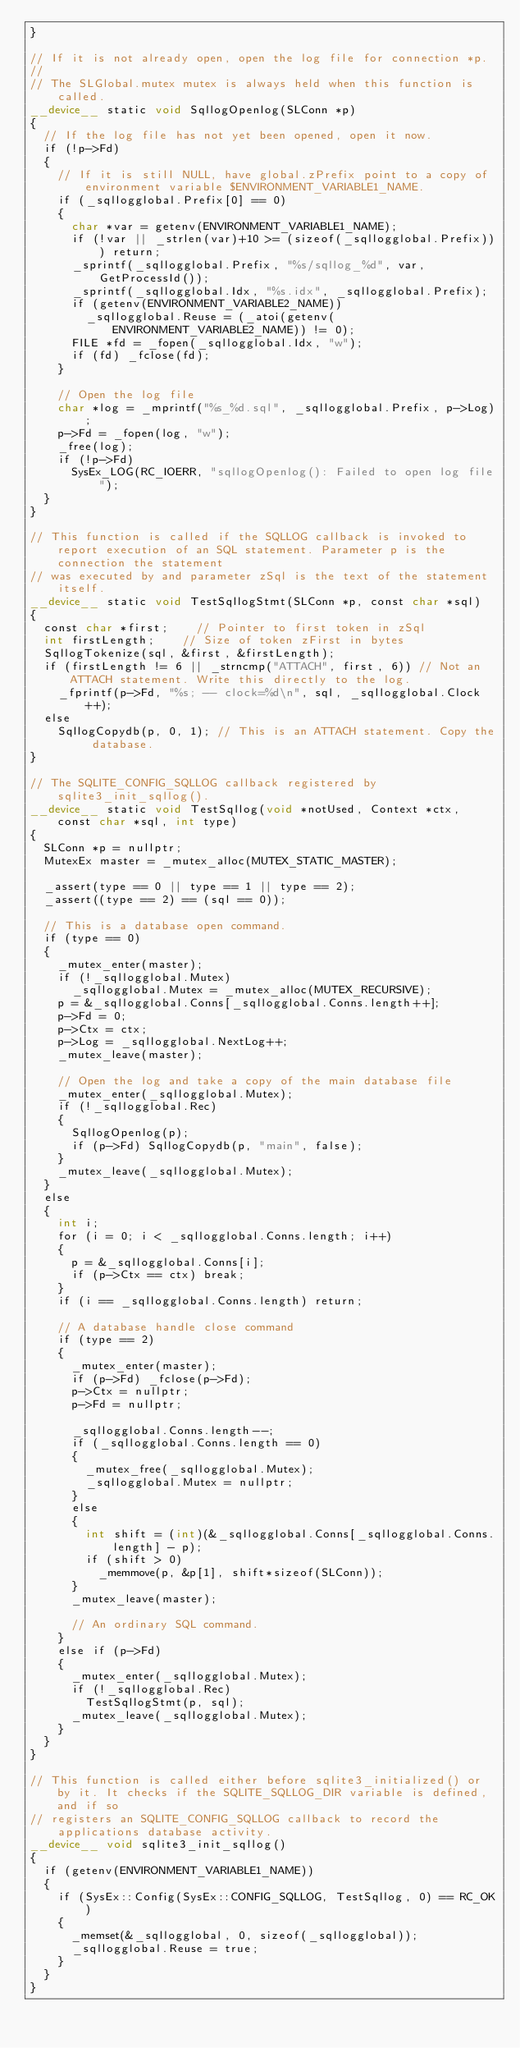Convert code to text. <code><loc_0><loc_0><loc_500><loc_500><_Cuda_>}

// If it is not already open, open the log file for connection *p. 
//
// The SLGlobal.mutex mutex is always held when this function is called.
__device__ static void SqllogOpenlog(SLConn *p)
{
	// If the log file has not yet been opened, open it now.
	if (!p->Fd)
	{
		// If it is still NULL, have global.zPrefix point to a copy of environment variable $ENVIRONMENT_VARIABLE1_NAME.
		if (_sqllogglobal.Prefix[0] == 0)
		{
			char *var = getenv(ENVIRONMENT_VARIABLE1_NAME);
			if (!var || _strlen(var)+10 >= (sizeof(_sqllogglobal.Prefix))) return;
			_sprintf(_sqllogglobal.Prefix, "%s/sqllog_%d", var, GetProcessId());
			_sprintf(_sqllogglobal.Idx, "%s.idx", _sqllogglobal.Prefix);
			if (getenv(ENVIRONMENT_VARIABLE2_NAME))
				_sqllogglobal.Reuse = (_atoi(getenv(ENVIRONMENT_VARIABLE2_NAME)) != 0);
			FILE *fd = _fopen(_sqllogglobal.Idx, "w");
			if (fd) _fclose(fd);
		}

		// Open the log file
		char *log = _mprintf("%s_%d.sql", _sqllogglobal.Prefix, p->Log);
		p->Fd = _fopen(log, "w");
		_free(log);
		if (!p->Fd)
			SysEx_LOG(RC_IOERR, "sqllogOpenlog(): Failed to open log file");
	}
}

// This function is called if the SQLLOG callback is invoked to report execution of an SQL statement. Parameter p is the connection the statement
// was executed by and parameter zSql is the text of the statement itself.
__device__ static void TestSqllogStmt(SLConn *p, const char *sql)
{
	const char *first;		// Pointer to first token in zSql
	int firstLength;		// Size of token zFirst in bytes
	SqllogTokenize(sql, &first, &firstLength);
	if (firstLength != 6 || _strncmp("ATTACH", first, 6)) // Not an ATTACH statement. Write this directly to the log.
		_fprintf(p->Fd, "%s; -- clock=%d\n", sql, _sqllogglobal.Clock++);
	else
		SqllogCopydb(p, 0, 1); // This is an ATTACH statement. Copy the database.
}

// The SQLITE_CONFIG_SQLLOG callback registered by sqlite3_init_sqllog().
__device__ static void TestSqllog(void *notUsed, Context *ctx, const char *sql, int type)
{
	SLConn *p = nullptr;
	MutexEx master = _mutex_alloc(MUTEX_STATIC_MASTER);

	_assert(type == 0 || type == 1 || type == 2);
	_assert((type == 2) == (sql == 0));

	// This is a database open command.
	if (type == 0)
	{
		_mutex_enter(master);
		if (!_sqllogglobal.Mutex)
			_sqllogglobal.Mutex = _mutex_alloc(MUTEX_RECURSIVE);
		p = &_sqllogglobal.Conns[_sqllogglobal.Conns.length++];
		p->Fd = 0;
		p->Ctx = ctx;
		p->Log = _sqllogglobal.NextLog++;
		_mutex_leave(master);

		// Open the log and take a copy of the main database file
		_mutex_enter(_sqllogglobal.Mutex);
		if (!_sqllogglobal.Rec)
		{
			SqllogOpenlog(p);
			if (p->Fd) SqllogCopydb(p, "main", false);
		}
		_mutex_leave(_sqllogglobal.Mutex);
	}
	else
	{
		int i;
		for (i = 0; i < _sqllogglobal.Conns.length; i++)
		{
			p = &_sqllogglobal.Conns[i];
			if (p->Ctx == ctx) break;
		}
		if (i == _sqllogglobal.Conns.length) return;

		// A database handle close command
		if (type == 2)
		{
			_mutex_enter(master);
			if (p->Fd) _fclose(p->Fd);
			p->Ctx = nullptr;
			p->Fd = nullptr;

			_sqllogglobal.Conns.length--;
			if (_sqllogglobal.Conns.length == 0)
			{
				_mutex_free(_sqllogglobal.Mutex);
				_sqllogglobal.Mutex = nullptr;
			}
			else
			{
				int shift = (int)(&_sqllogglobal.Conns[_sqllogglobal.Conns.length] - p);
				if (shift > 0)
					_memmove(p, &p[1], shift*sizeof(SLConn));
			}
			_mutex_leave(master);

			// An ordinary SQL command.
		}
		else if (p->Fd)
		{
			_mutex_enter(_sqllogglobal.Mutex);
			if (!_sqllogglobal.Rec)
				TestSqllogStmt(p, sql);
			_mutex_leave(_sqllogglobal.Mutex);
		}
	}
}

// This function is called either before sqlite3_initialized() or by it. It checks if the SQLITE_SQLLOG_DIR variable is defined, and if so 
// registers an SQLITE_CONFIG_SQLLOG callback to record the applications database activity.
__device__ void sqlite3_init_sqllog()
{
	if (getenv(ENVIRONMENT_VARIABLE1_NAME))
	{
		if (SysEx::Config(SysEx::CONFIG_SQLLOG, TestSqllog, 0) == RC_OK)
		{
			_memset(&_sqllogglobal, 0, sizeof(_sqllogglobal));
			_sqllogglobal.Reuse = true;
		}
	}
}
</code> 